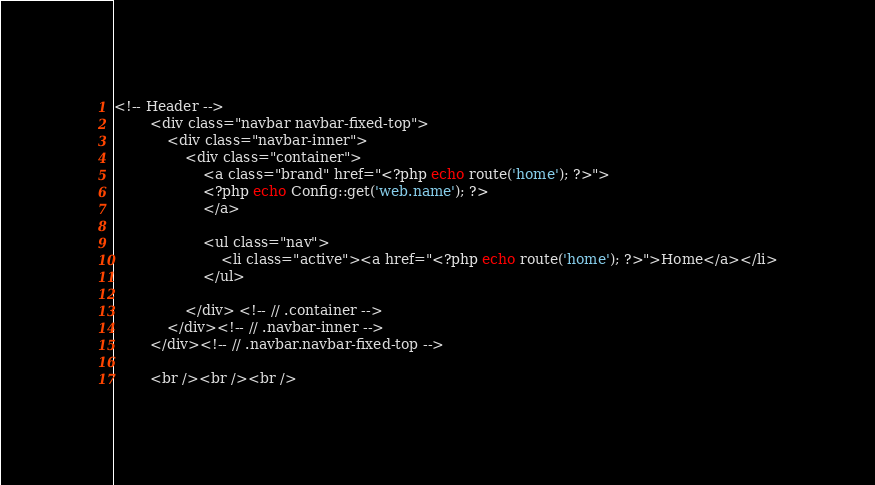<code> <loc_0><loc_0><loc_500><loc_500><_PHP_><!-- Header -->
		<div class="navbar navbar-fixed-top">
			<div class="navbar-inner">
				<div class="container">
					<a class="brand" href="<?php echo route('home'); ?>">
					<?php echo Config::get('web.name'); ?>
					</a>
					
					<ul class="nav">
						<li class="active"><a href="<?php echo route('home'); ?>">Home</a></li>
					</ul>
					
				</div> <!-- // .container -->
			</div><!-- // .navbar-inner -->
		</div><!-- // .navbar.navbar-fixed-top -->
		
		<br /><br /><br /></code> 